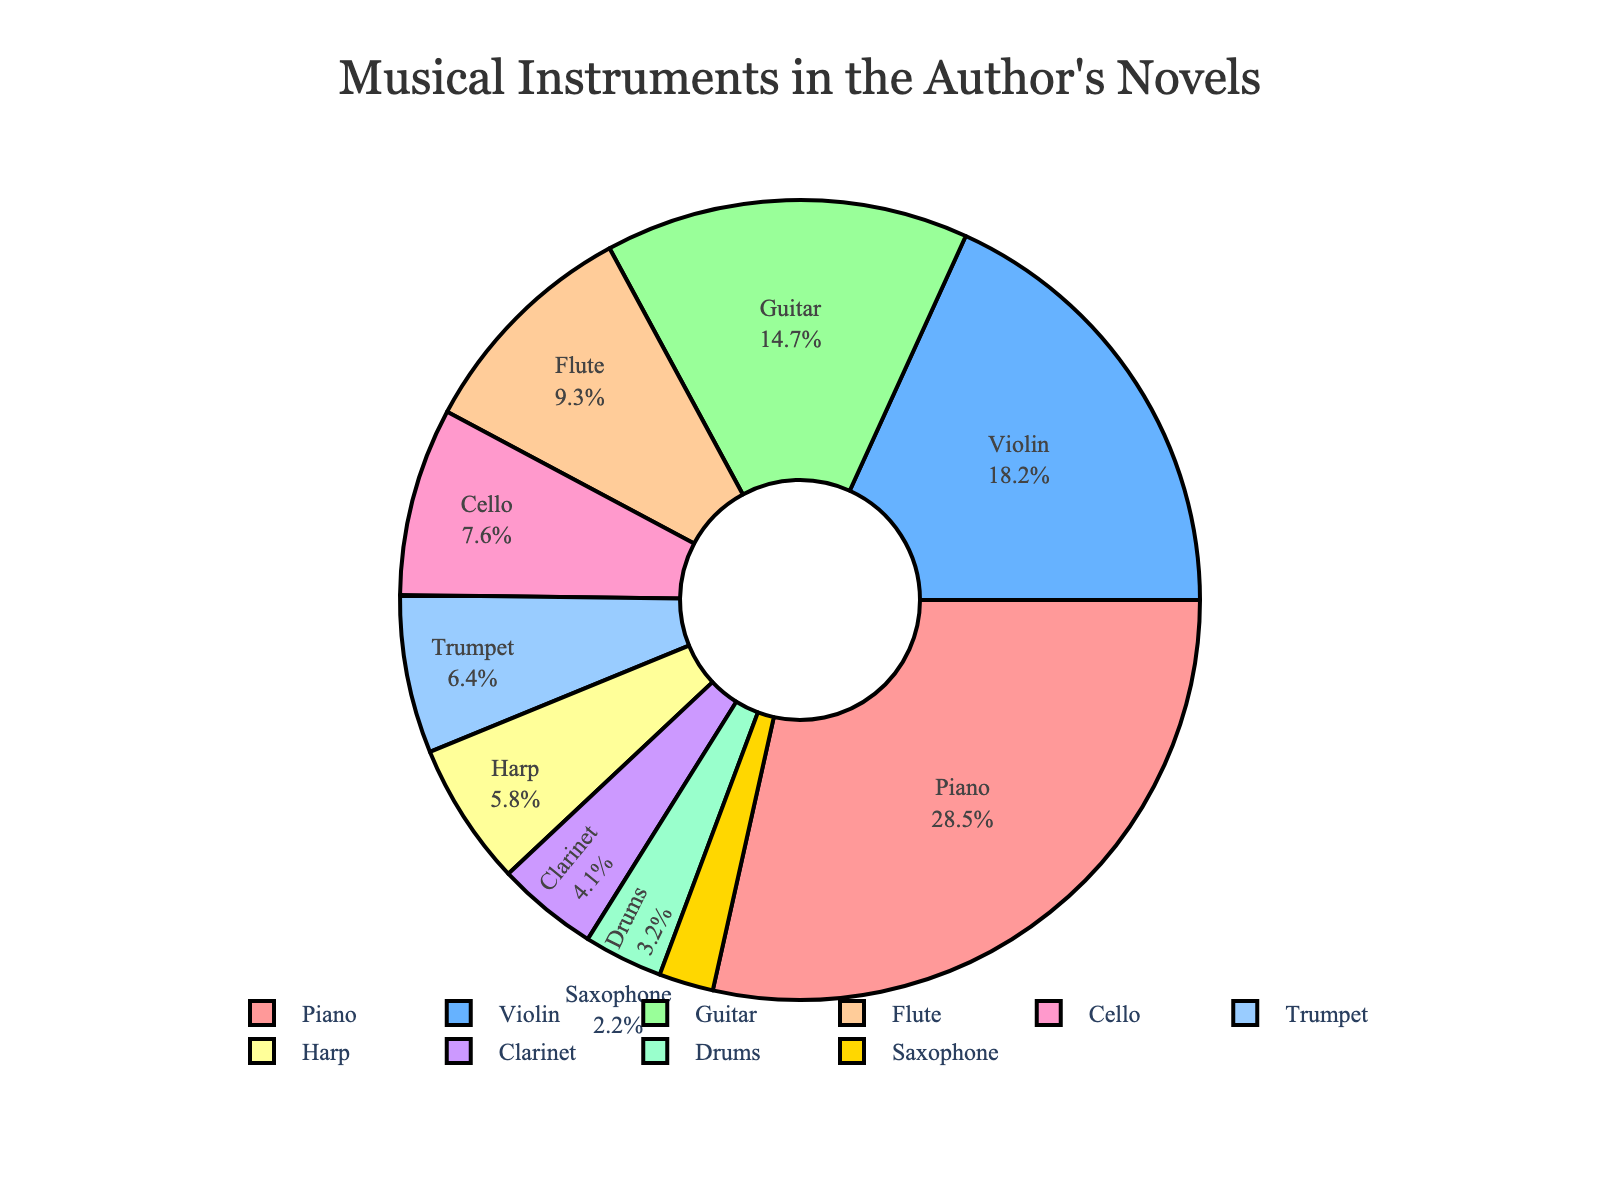what is the most mentioned instrument? The most mentioned instrument is identified as the one with the largest percentage in the pie chart. Here, the largest section belongs to the Piano.
Answer: Piano How much more is the percentage for Piano compared to Guitar? To find how much more the Piano is mentioned compared to Guitar, subtract the Guitar's percentage (14.7%) from the Piano's percentage (28.5%). 28.5 - 14.7 = 13.8
Answer: 13.8% Which two instruments combined make up the smallest percentage? To determine this, identify the two smallest percentages in the chart, which are Saxophone (2.2%) and Drums (3.2%). 2.2 + 3.2 = 5.4
Answer: Saxophone and Drums What is the total percentage of string instruments mentioned? String instruments in the data are Piano (28.5%), Violin (18.2%), Guitar (14.7%), and Cello (7.6%). Sum these percentages: 28.5 + 18.2 + 14.7 + 7.6 = 69
Answer: 69% Which instrument has nearly half the percentage of the one with the highest mention? Find the highest percentage (Piano: 28.5%). Half of 28.5 is approximately 14.25. The closest percentages to 14.25 are Guitar (14.7%).
Answer: Guitar If you exclude the four most mentioned instruments, what is the total percentage of the remaining instruments? Identify the four most mentioned instruments: Piano (28.5%), Violin (18.2%), Guitar (14.7%), and Flute (9.3%). Sum their percentages: 28.5 + 18.2 + 14.7 + 9.3 = 70.7. Subtract this from 100: 100 - 70.7 = 29.3
Answer: 29.3% Which has a greater percentage, Cello or Trumpet, and by how much? Compare the percentages for Cello (7.6%) and Trumpet (6.4%). Subtract the smaller percentage from the larger one: 7.6 - 6.4 = 1.2
Answer: Cello by 1.2% List the instruments mentioned less than 5% of the time. Identify all instruments with percentages below 5%: Clarinet (4.1%), Drums (3.2%), and Saxophone (2.2%).
Answer: Clarinet, Drums, Saxophone What percentage more is the Flute mentioned compared to the Harp? Compare the percentages for Flute (9.3%) and Harp (5.8%). Subtract the Harp's percentage from the Flute's percentage: 9.3 - 5.8 = 3.5
Answer: 3.5% If the percentages for Trumpet and Harp were combined into one category, what would the new percentage be? Sum the percentages for Trumpet (6.4%) and Harp (5.8%): 6.4 + 5.8 = 12.2
Answer: 12.2% 